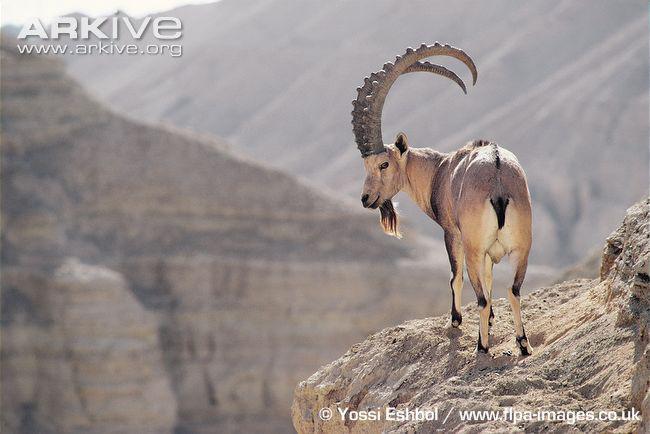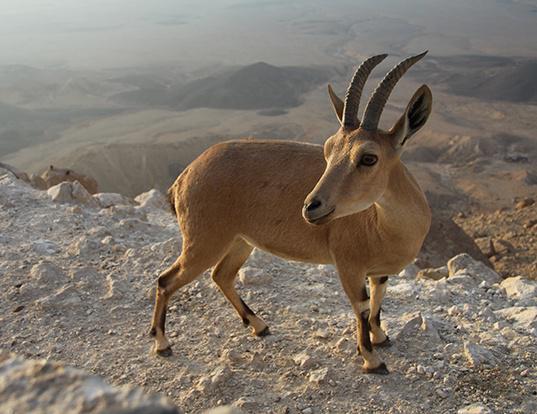The first image is the image on the left, the second image is the image on the right. Considering the images on both sides, is "In one image, an antelope is resting with its body on the ground." valid? Answer yes or no. No. The first image is the image on the left, the second image is the image on the right. Given the left and right images, does the statement "There is exactly one sitting animal in the image on the right." hold true? Answer yes or no. No. 